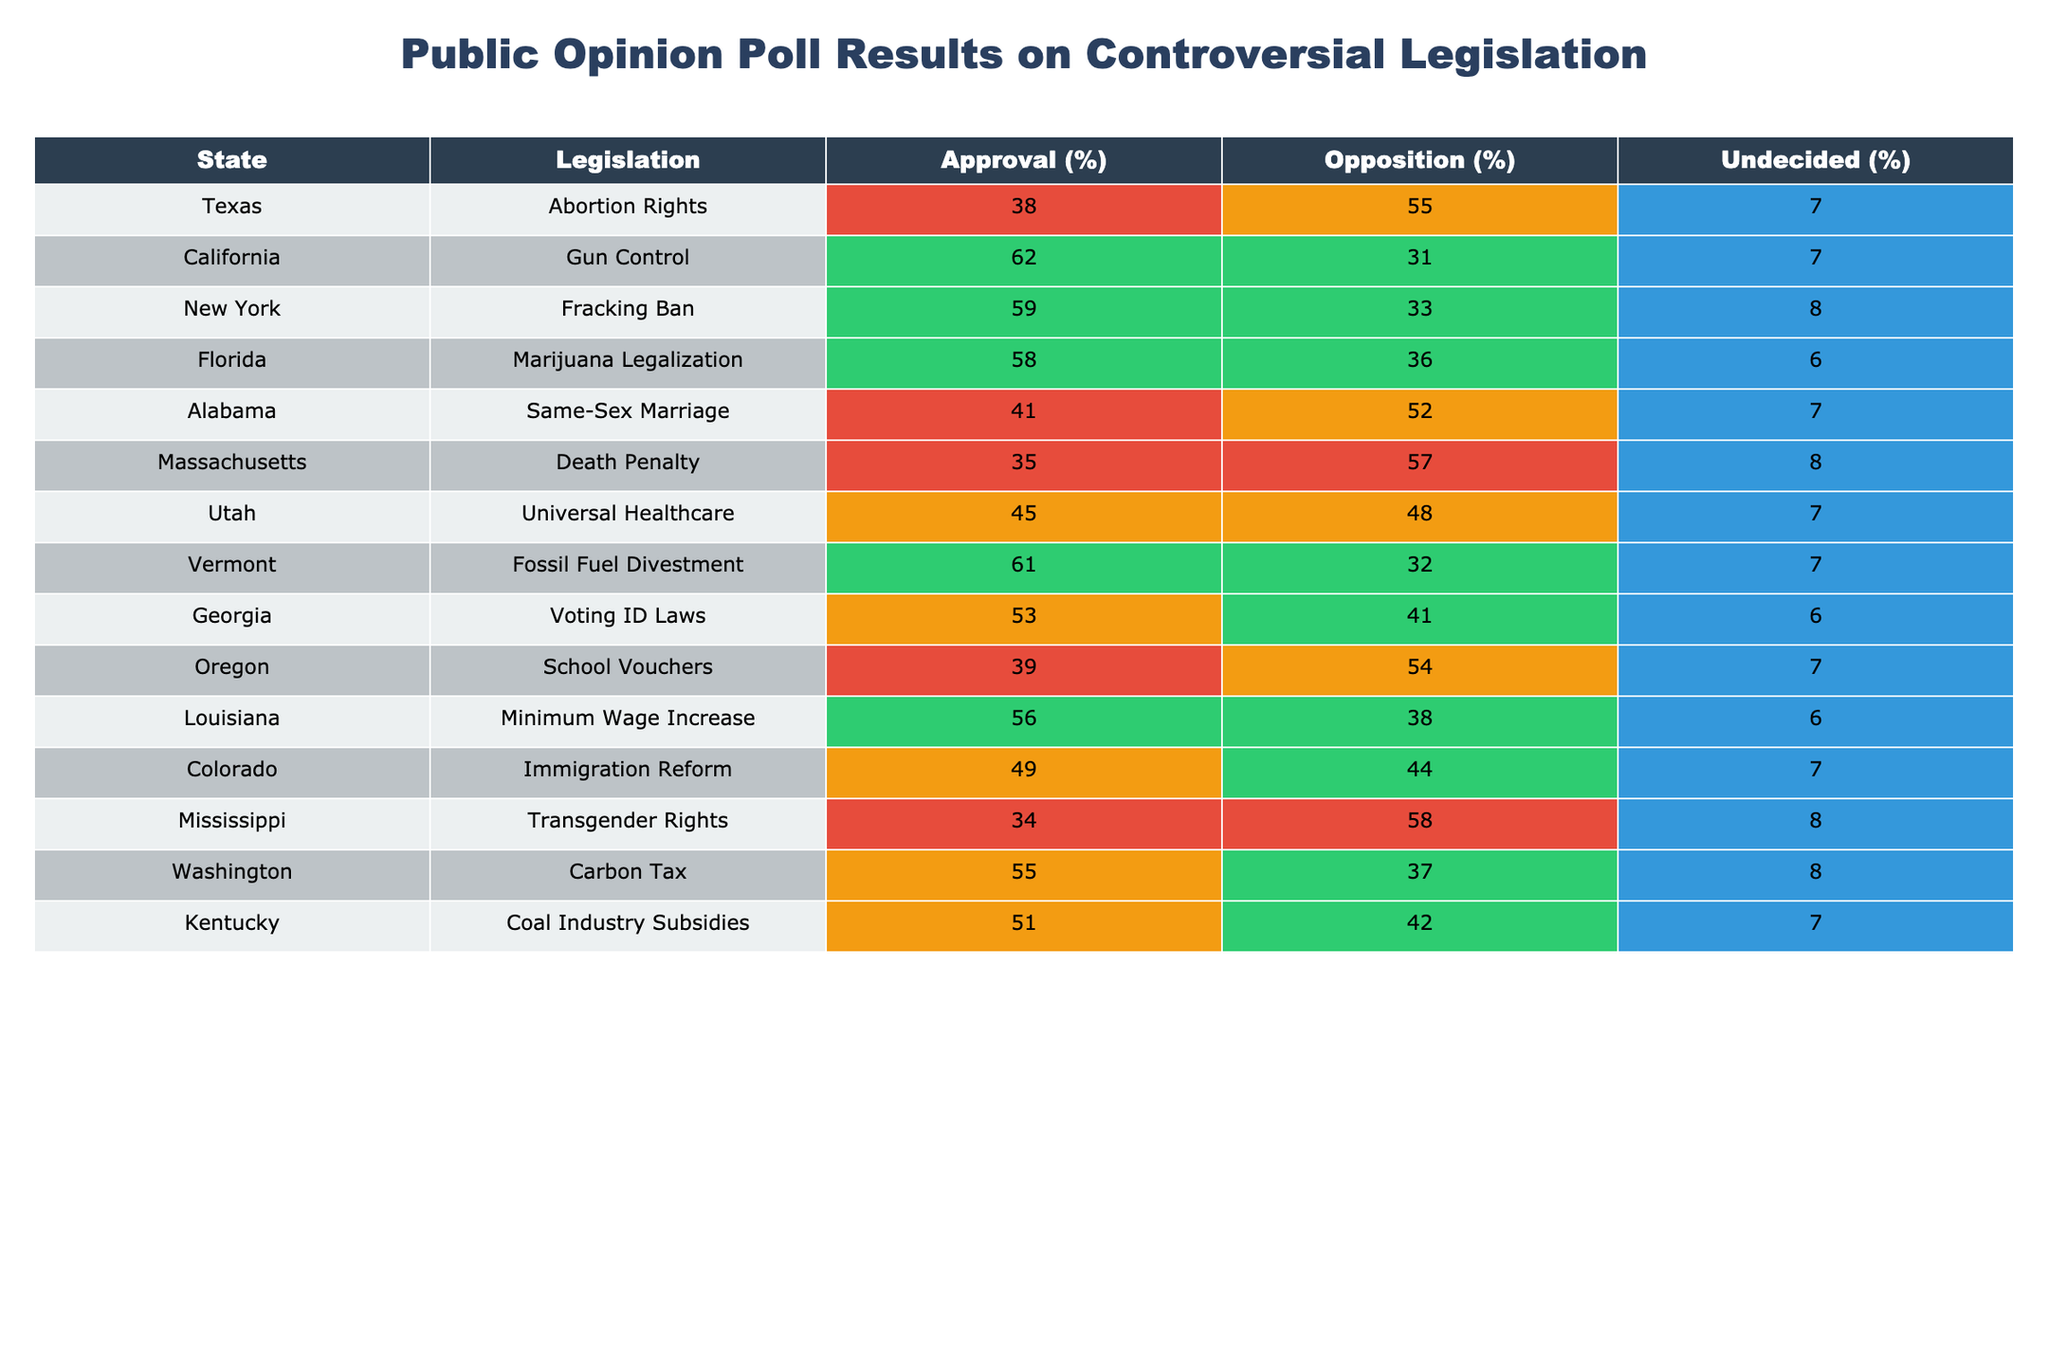What percentage of Californians approve of Gun Control legislation? Looking at the table under the "California" row and the "Approval (%)" column, the value is 62%.
Answer: 62% Which state has the highest approval for fossil fuel divestment? The table shows that Vermont has an approval rating of 61% for Fossil Fuel Divestment, which is the highest among the options given.
Answer: Vermont Is the opposition to Abortion Rights in Texas higher than 50%? The table indicates that Texas has an opposition percentage of 55%, which is indeed higher than 50%.
Answer: Yes What is the difference in approval percentages between Georgia's Voting ID Laws and Oregon's School Vouchers? Georgia has an approval percentage of 53% for Voting ID Laws, while Oregon has 39% approval for School Vouchers. The difference is 53% - 39% = 14%.
Answer: 14% What is the average approval percentage across all legislation listed in the table? To find the average, sum all approval percentages: 38 + 62 + 59 + 58 + 41 + 35 + 45 + 61 + 53 + 39 + 56 + 49 + 34 + 55 + 51 =  51. The total is 15 legislation points, so the average is 51/15 = 3.4.
Answer: 51 Which state has the lowest approval for Same-Sex Marriage? The table shows Alabama has an approval rating of 41%, which is lower compared to the other states' approval percentages for their respective legislations.
Answer: Alabama Is it true that more states have an approval percentage above 50% than below 50%? By counting, there are 8 states above 50% approval and 7 states below 50% approval, so it is true.
Answer: Yes If you combined the approval percentages for Marijuana Legalization in Florida and Carbon Tax in Washington, what would that total? Florida's approval is 58% and Washington's is 55%. Adding those together gives 58% + 55% = 113%.
Answer: 113% Which piece of legislation has the least amount of undecided voters? By checking the "Undecided (%)" column, both Florida's Marijuana Legalization and Louisiana's Minimum Wage Increase have 6% undecided voters, which is the least among all.
Answer: Florida and Louisiana How does the approval rating of Transgender Rights in Mississippi compare to that of Same-Sex Marriage in Alabama? Mississippi has an approval of 34%, while Alabama's approval is 41%. Therefore, Alabama's approval is higher by 7%.
Answer: Alabama How many legislation pieces have an approval rating of exactly 35%? The table shows that only Massachusetts, with a Death Penalty approval of 35%, fits this criterion. Thus, the count is 1.
Answer: 1 